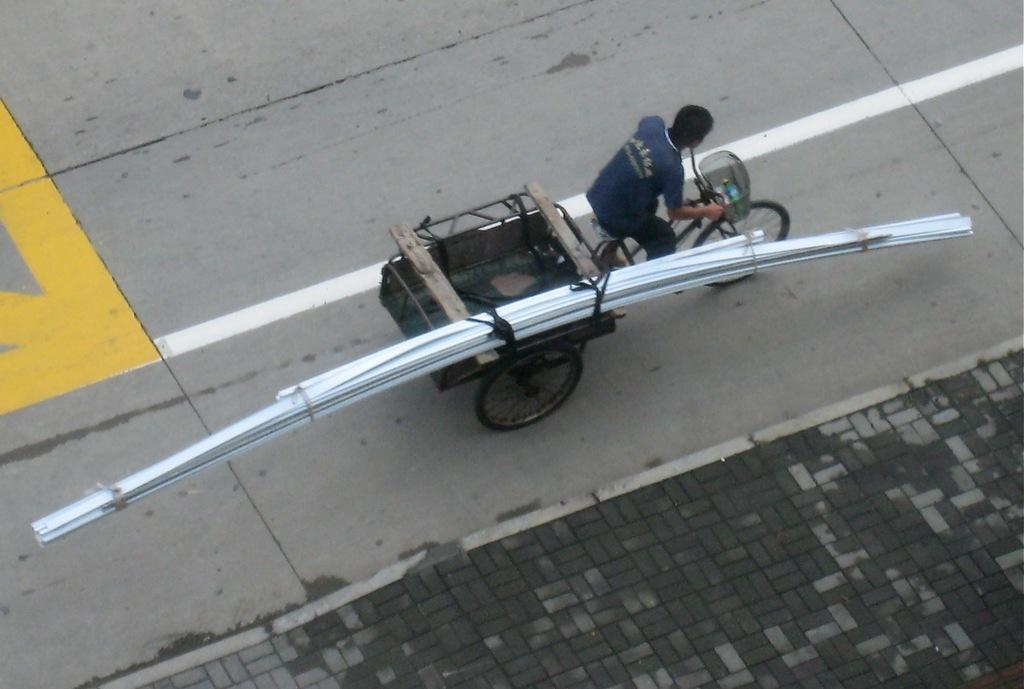What is happening in the image? There is a person in the image who is riding a vehicle. What type of vehicle is the person riding? The vehicle is on the road, but the specific type of vehicle is not mentioned in the facts. What is attached to the vehicle? Iron bars are tied to the vehicle. What type of beef is being wasted by the person in the image? There is no beef or waste mentioned in the image; it only shows a person riding a vehicle with iron bars attached. 